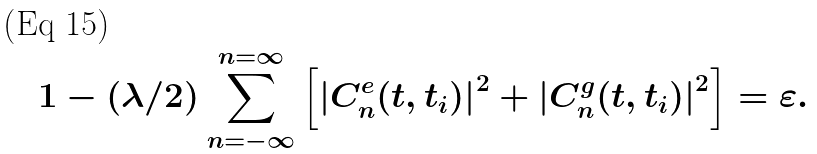<formula> <loc_0><loc_0><loc_500><loc_500>1 - ( \lambda / 2 ) \sum _ { n = - \infty } ^ { n = \infty } \left [ { | C ^ { e } _ { n } ( t , t _ { i } ) | } ^ { 2 } + { | C ^ { g } _ { n } ( t , t _ { i } ) | } ^ { 2 } \right ] = \varepsilon .</formula> 